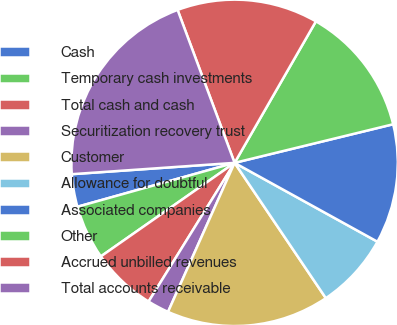<chart> <loc_0><loc_0><loc_500><loc_500><pie_chart><fcel>Cash<fcel>Temporary cash investments<fcel>Total cash and cash<fcel>Securitization recovery trust<fcel>Customer<fcel>Allowance for doubtful<fcel>Associated companies<fcel>Other<fcel>Accrued unbilled revenues<fcel>Total accounts receivable<nl><fcel>3.23%<fcel>5.38%<fcel>6.45%<fcel>2.15%<fcel>16.13%<fcel>7.53%<fcel>11.83%<fcel>12.9%<fcel>13.98%<fcel>20.43%<nl></chart> 